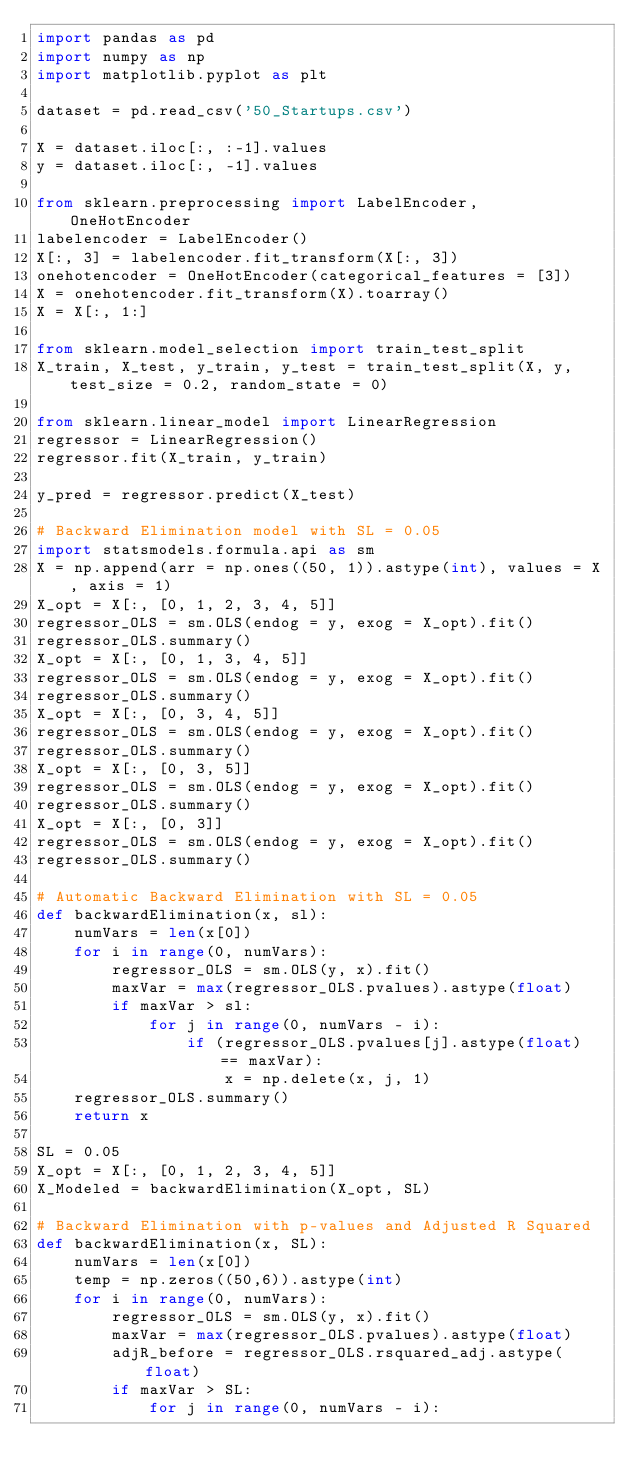Convert code to text. <code><loc_0><loc_0><loc_500><loc_500><_Python_>import pandas as pd
import numpy as np
import matplotlib.pyplot as plt

dataset = pd.read_csv('50_Startups.csv')

X = dataset.iloc[:, :-1].values
y = dataset.iloc[:, -1].values

from sklearn.preprocessing import LabelEncoder, OneHotEncoder
labelencoder = LabelEncoder()
X[:, 3] = labelencoder.fit_transform(X[:, 3])
onehotencoder = OneHotEncoder(categorical_features = [3])
X = onehotencoder.fit_transform(X).toarray()
X = X[:, 1:]

from sklearn.model_selection import train_test_split
X_train, X_test, y_train, y_test = train_test_split(X, y, test_size = 0.2, random_state = 0)

from sklearn.linear_model import LinearRegression
regressor = LinearRegression()
regressor.fit(X_train, y_train)

y_pred = regressor.predict(X_test)

# Backward Elimination model with SL = 0.05
import statsmodels.formula.api as sm
X = np.append(arr = np.ones((50, 1)).astype(int), values = X, axis = 1)
X_opt = X[:, [0, 1, 2, 3, 4, 5]]
regressor_OLS = sm.OLS(endog = y, exog = X_opt).fit()
regressor_OLS.summary()
X_opt = X[:, [0, 1, 3, 4, 5]]
regressor_OLS = sm.OLS(endog = y, exog = X_opt).fit()
regressor_OLS.summary()
X_opt = X[:, [0, 3, 4, 5]]
regressor_OLS = sm.OLS(endog = y, exog = X_opt).fit()
regressor_OLS.summary()
X_opt = X[:, [0, 3, 5]]
regressor_OLS = sm.OLS(endog = y, exog = X_opt).fit()
regressor_OLS.summary()
X_opt = X[:, [0, 3]]
regressor_OLS = sm.OLS(endog = y, exog = X_opt).fit()
regressor_OLS.summary()

# Automatic Backward Elimination with SL = 0.05
def backwardElimination(x, sl):
    numVars = len(x[0])
    for i in range(0, numVars):
        regressor_OLS = sm.OLS(y, x).fit()
        maxVar = max(regressor_OLS.pvalues).astype(float)
        if maxVar > sl:
            for j in range(0, numVars - i):
                if (regressor_OLS.pvalues[j].astype(float) == maxVar):
                    x = np.delete(x, j, 1)
    regressor_OLS.summary()
    return x
 
SL = 0.05
X_opt = X[:, [0, 1, 2, 3, 4, 5]]
X_Modeled = backwardElimination(X_opt, SL)

# Backward Elimination with p-values and Adjusted R Squared
def backwardElimination(x, SL):
    numVars = len(x[0])
    temp = np.zeros((50,6)).astype(int)
    for i in range(0, numVars):
        regressor_OLS = sm.OLS(y, x).fit()
        maxVar = max(regressor_OLS.pvalues).astype(float)
        adjR_before = regressor_OLS.rsquared_adj.astype(float)
        if maxVar > SL:
            for j in range(0, numVars - i):</code> 